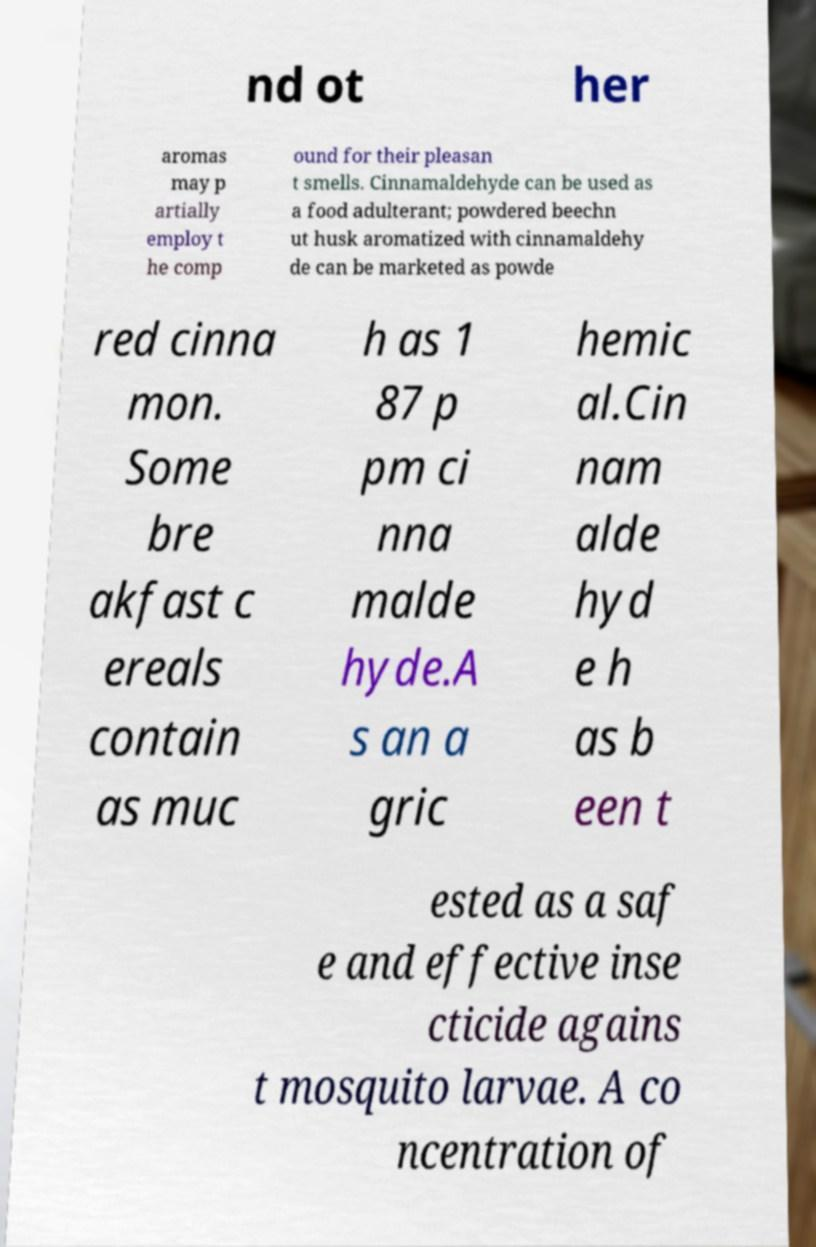What messages or text are displayed in this image? I need them in a readable, typed format. nd ot her aromas may p artially employ t he comp ound for their pleasan t smells. Cinnamaldehyde can be used as a food adulterant; powdered beechn ut husk aromatized with cinnamaldehy de can be marketed as powde red cinna mon. Some bre akfast c ereals contain as muc h as 1 87 p pm ci nna malde hyde.A s an a gric hemic al.Cin nam alde hyd e h as b een t ested as a saf e and effective inse cticide agains t mosquito larvae. A co ncentration of 